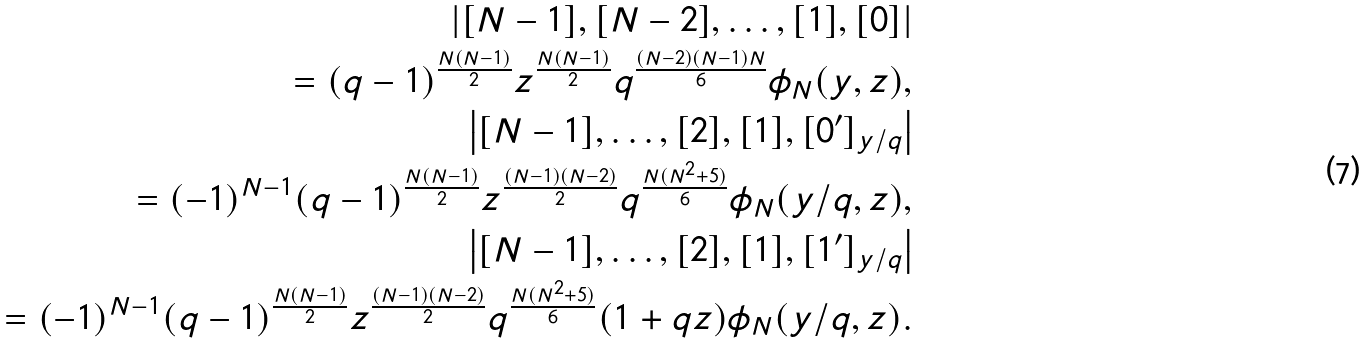Convert formula to latex. <formula><loc_0><loc_0><loc_500><loc_500>\left | [ N - 1 ] , [ N - 2 ] , \dots , [ 1 ] , [ 0 ] \right | \\ = ( q - 1 ) ^ { \frac { N ( N - 1 ) } { 2 } } z ^ { \frac { N ( N - 1 ) } { 2 } } q ^ { \frac { ( N - 2 ) ( N - 1 ) N } { 6 } } \phi _ { N } ( y , z ) , \\ \left | [ N - 1 ] , \dots , [ 2 ] , [ 1 ] , [ 0 ^ { \prime } ] _ { y / q } \right | \\ = ( - 1 ) ^ { N - 1 } ( q - 1 ) ^ { \frac { N ( N - 1 ) } { 2 } } z ^ { \frac { ( N - 1 ) ( N - 2 ) } { 2 } } q ^ { \frac { N ( N ^ { 2 } + 5 ) } { 6 } } \phi _ { N } ( y / q , z ) , \\ \left | [ N - 1 ] , \dots , [ 2 ] , [ 1 ] , [ 1 ^ { \prime } ] _ { y / q } \right | \\ = ( - 1 ) ^ { N - 1 } ( q - 1 ) ^ { \frac { N ( N - 1 ) } { 2 } } z ^ { \frac { ( N - 1 ) ( N - 2 ) } { 2 } } q ^ { \frac { N ( N ^ { 2 } + 5 ) } { 6 } } ( 1 + q z ) \phi _ { N } ( y / q , z ) .</formula> 